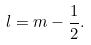Convert formula to latex. <formula><loc_0><loc_0><loc_500><loc_500>l = m - \frac { 1 } { 2 } .</formula> 